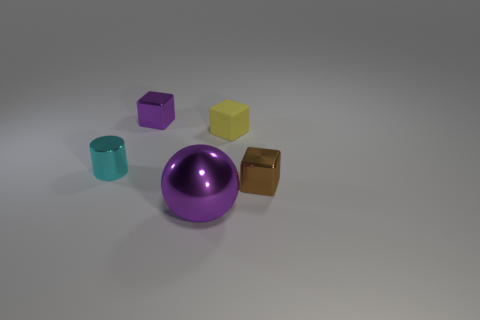Which objects in the image appear to have reflective surfaces? The purple and bronze cubes, the aqua cylinder, and the large purple sphere display reflective surfaces, suggesting they are made of materials like metal or plastic, which have been polished or treated to have a shiny finish. 